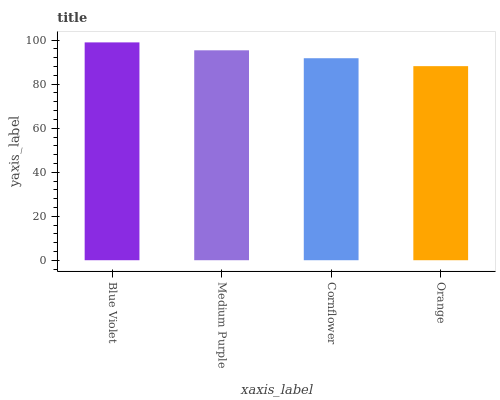Is Orange the minimum?
Answer yes or no. Yes. Is Blue Violet the maximum?
Answer yes or no. Yes. Is Medium Purple the minimum?
Answer yes or no. No. Is Medium Purple the maximum?
Answer yes or no. No. Is Blue Violet greater than Medium Purple?
Answer yes or no. Yes. Is Medium Purple less than Blue Violet?
Answer yes or no. Yes. Is Medium Purple greater than Blue Violet?
Answer yes or no. No. Is Blue Violet less than Medium Purple?
Answer yes or no. No. Is Medium Purple the high median?
Answer yes or no. Yes. Is Cornflower the low median?
Answer yes or no. Yes. Is Cornflower the high median?
Answer yes or no. No. Is Medium Purple the low median?
Answer yes or no. No. 